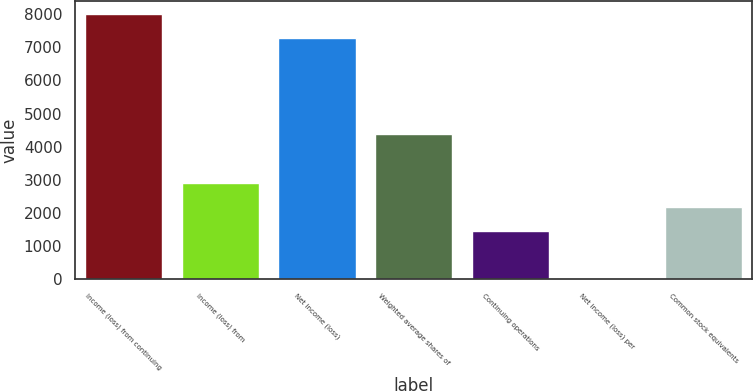<chart> <loc_0><loc_0><loc_500><loc_500><bar_chart><fcel>Income (loss) from continuing<fcel>Income (loss) from<fcel>Net income (loss)<fcel>Weighted average shares of<fcel>Continuing operations<fcel>Net income (loss) per<fcel>Common stock equivalents<nl><fcel>7993.86<fcel>2917.81<fcel>7266<fcel>4373.55<fcel>1462.09<fcel>6.35<fcel>2189.95<nl></chart> 